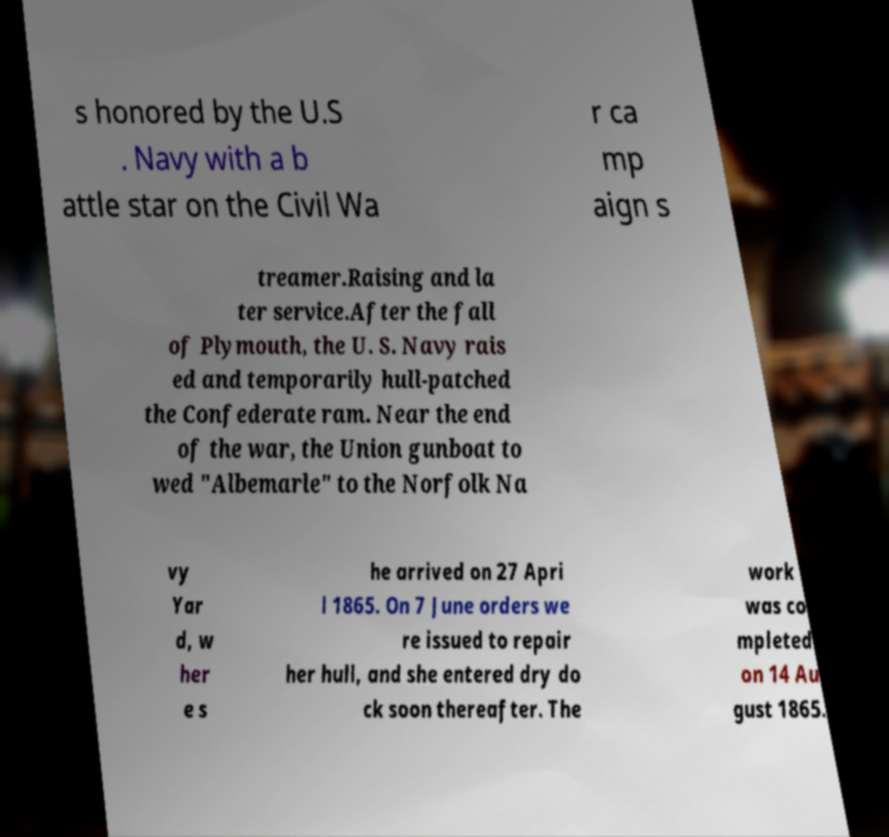Please identify and transcribe the text found in this image. s honored by the U.S . Navy with a b attle star on the Civil Wa r ca mp aign s treamer.Raising and la ter service.After the fall of Plymouth, the U. S. Navy rais ed and temporarily hull-patched the Confederate ram. Near the end of the war, the Union gunboat to wed "Albemarle" to the Norfolk Na vy Yar d, w her e s he arrived on 27 Apri l 1865. On 7 June orders we re issued to repair her hull, and she entered dry do ck soon thereafter. The work was co mpleted on 14 Au gust 1865. 